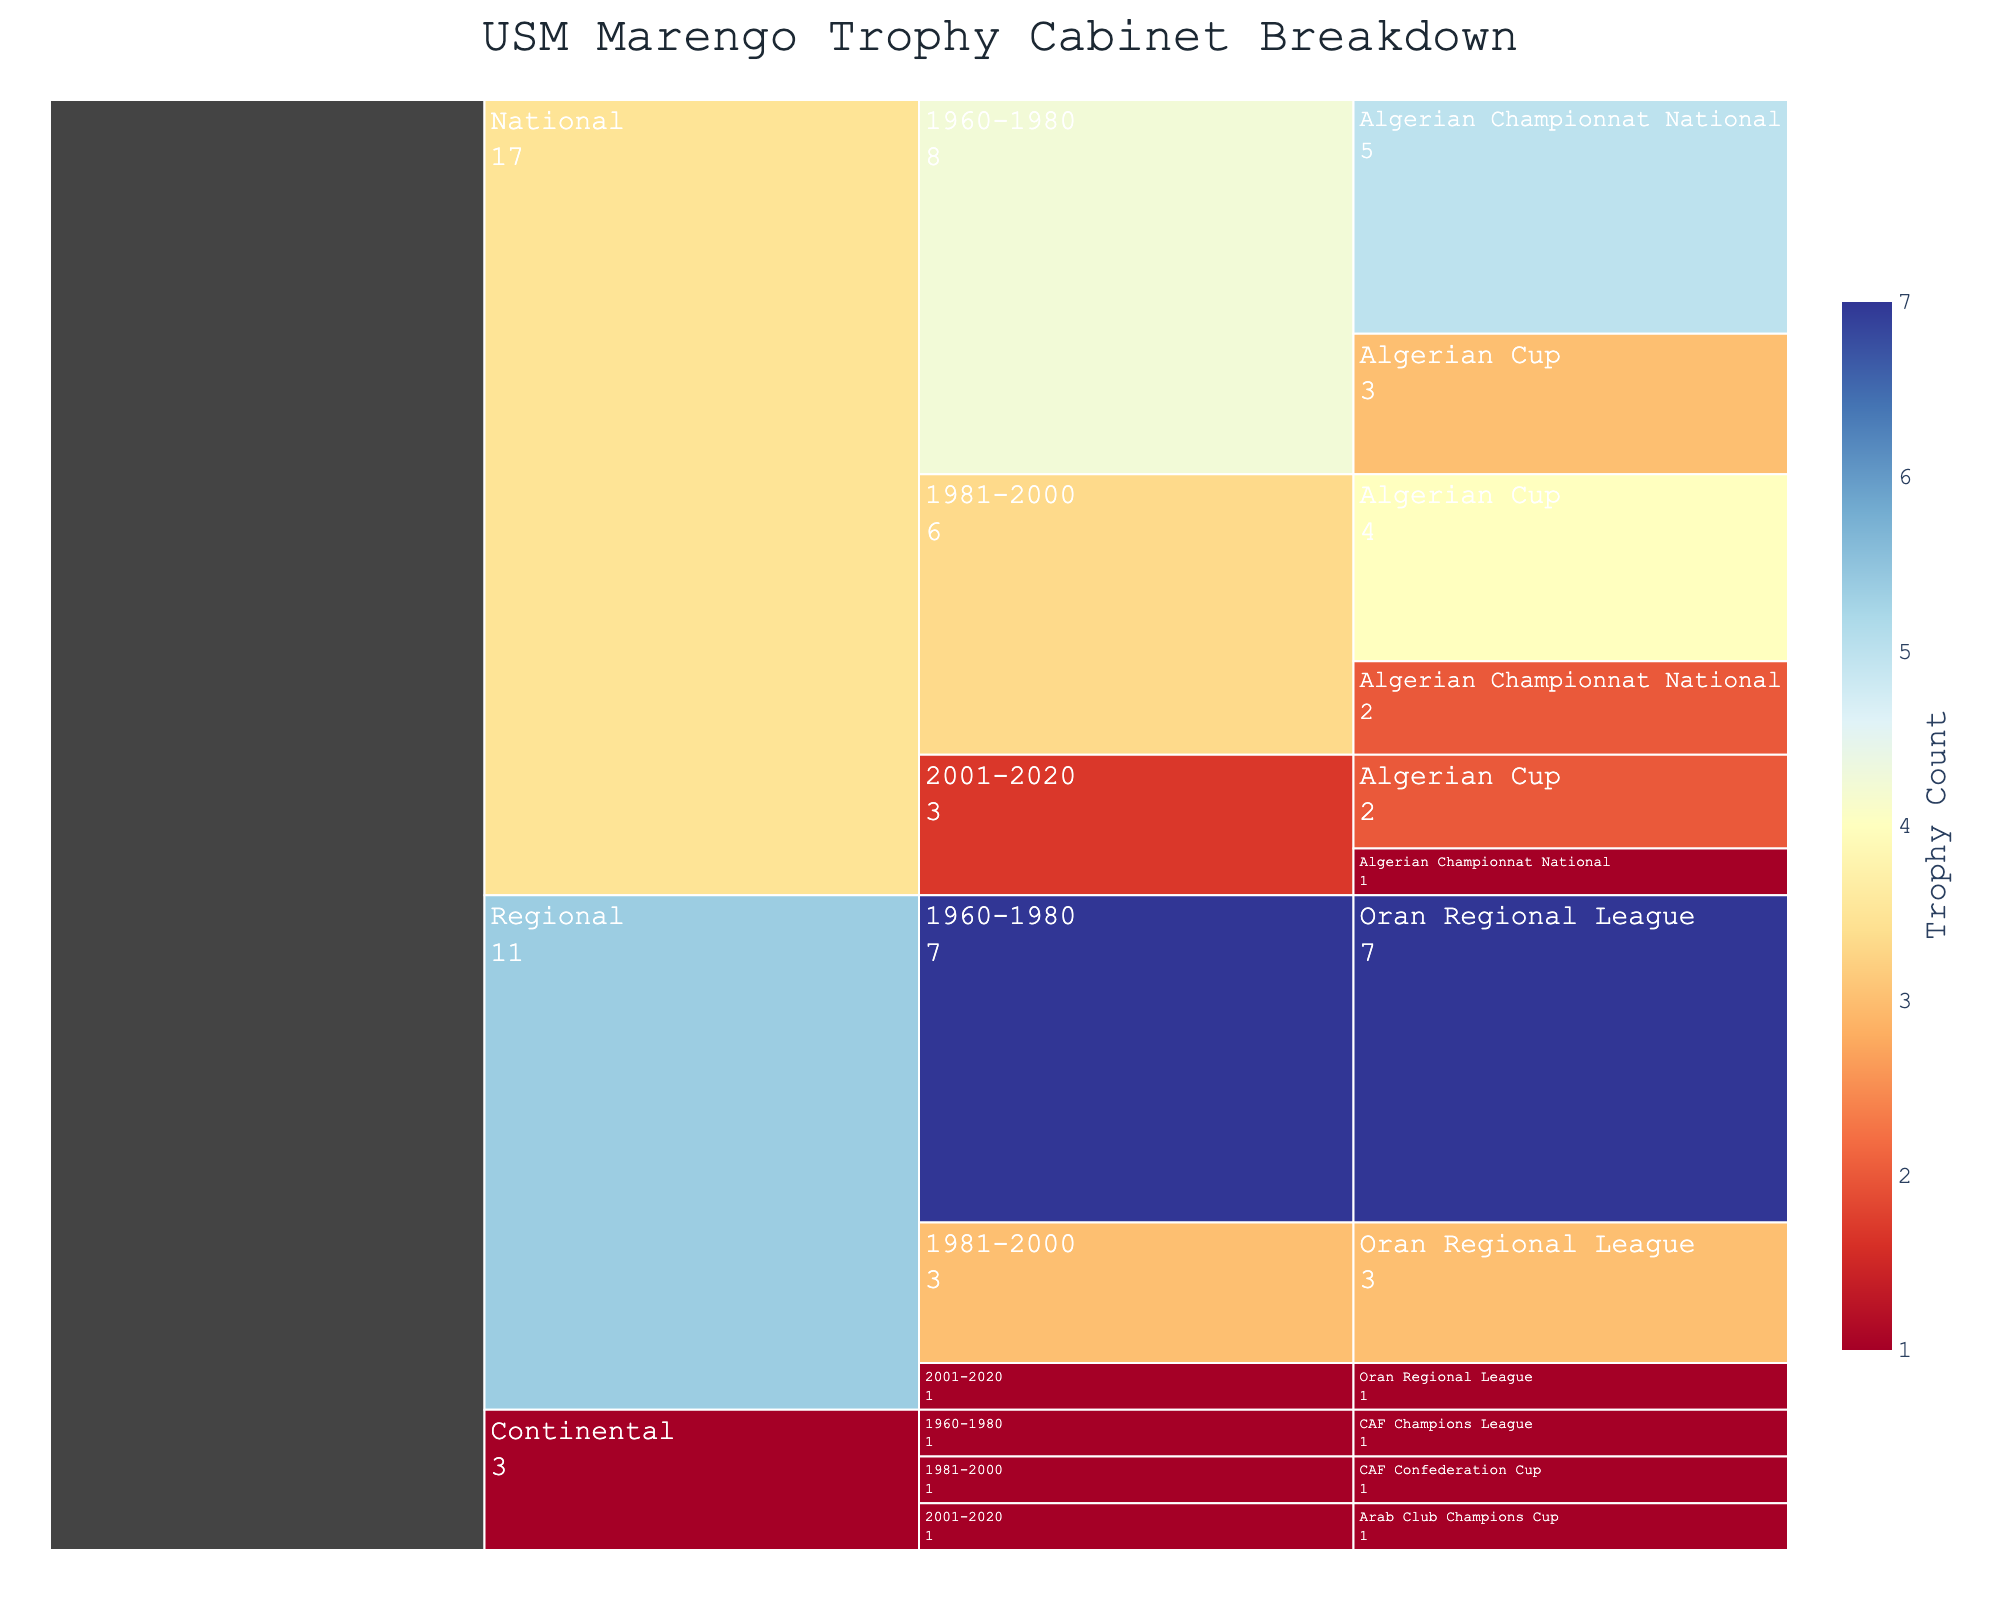What's the title of the icicle chart? The title is usually the most prominent text at the top of the visualization. It provides an overview of what the chart is about. In this case, it should clearly describe that the chart is about the breakdown of trophies.
Answer: USM Marengo Trophy Cabinet Breakdown How many trophies did USM Marengo win in the Oran Regional League from 1960 to 1980? Locate the section for the Regional competition, then look for the period 1960-1980 and the count under Oran Regional League. The count is the number of trophies won during that period.
Answer: 7 Which period did USM Marengo win the most Algerian Cup trophies? Compare the counts for the Algerian Cup across different periods within the National competition. The highest count indicates the period with the most trophies won.
Answer: 1981-2000 What's the total number of trophies won in the National competition? Sum the counts of all trophies listed under the National competition, regardless of the period. Add the three periods' counts together.
Answer: 17 How many more Oran Regional League trophies were won from 1960 to 1980 compared to 1981 to 2000? Subtract the number of Oran Regional League trophies won from 1981-2000 from the number won from 1960-1980. The difference gives the number of additional trophies won.
Answer: 4 What's the average number of trophies won across all periods for the CAF competitions listed? Sum the counts for all CAF trophies across different periods and divide by the number of periods (3). Average = (1 + 1 + 1)/3 = 1
Answer: 1 Compare the number of trophies won in the National competition from 1981-2000 to the total number of Regional trophies. Which one is greater? Compare the total counts: National (1981-2000) = (2 + 4) = 6; Total Regional = (7 + 3 + 1) = 11. The Regional total is greater.
Answer: Regional Which type of trophy has the smallest number of wins in the period 2001-2020? Examine the counts for the period 2001-2020 across all competitions and identify the least count. The smallest value indicates the least number of wins.
Answer: Oran Regional League (1) What is the total number of trophies won in the Continental competitions from 1960-2020? Sum the counts of all Continental competition trophies across all periods. Sum = 1 (CAF Champions League) + 1 (CAF Confederation Cup) + 1 (Arab Club Champions Cup) = 3
Answer: 3 